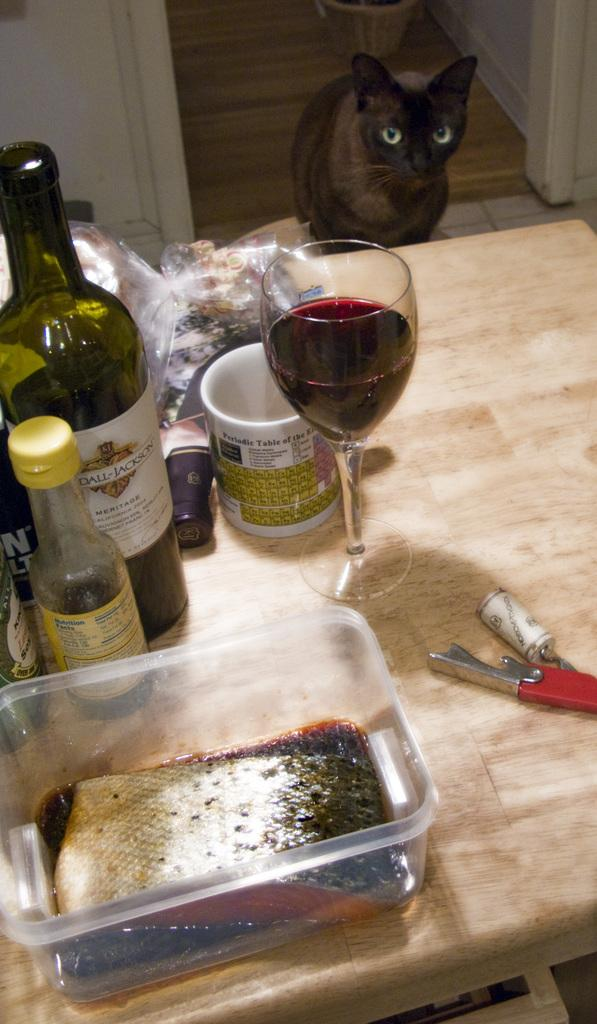What piece of furniture is present in the image? There is a table in the image. What is on the table? There is a red wine glass, a bottle, and a plastic packet on the table. What type of drink might be in the wine glass? The wine glass suggests that there might be red wine in it. Is there any living creature visible in the image? Yes, there is a cat on the ground. What type of pipe can be seen in the image? There is no pipe present in the image. What does the fiction smell like in the image? There is no fiction present in the image, and therefore it cannot have a smell. 